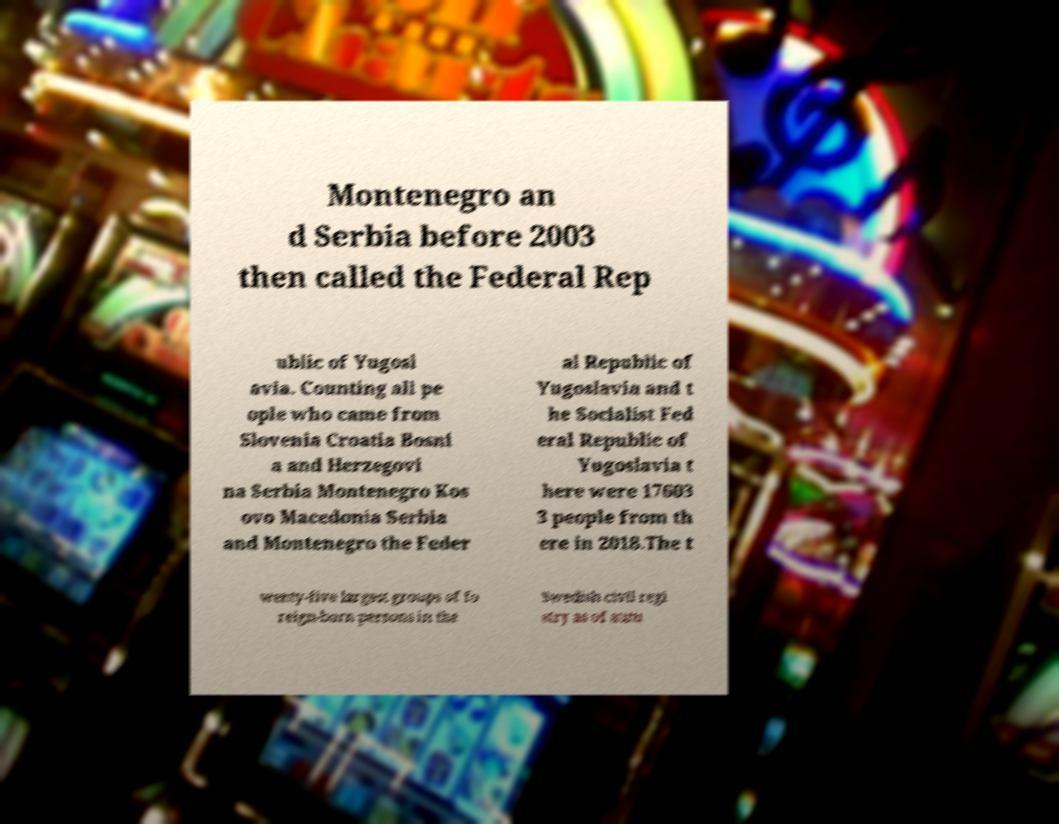For documentation purposes, I need the text within this image transcribed. Could you provide that? Montenegro an d Serbia before 2003 then called the Federal Rep ublic of Yugosl avia. Counting all pe ople who came from Slovenia Croatia Bosni a and Herzegovi na Serbia Montenegro Kos ovo Macedonia Serbia and Montenegro the Feder al Republic of Yugoslavia and t he Socialist Fed eral Republic of Yugoslavia t here were 17603 3 people from th ere in 2018.The t wenty-five largest groups of fo reign-born persons in the Swedish civil regi stry as of autu 